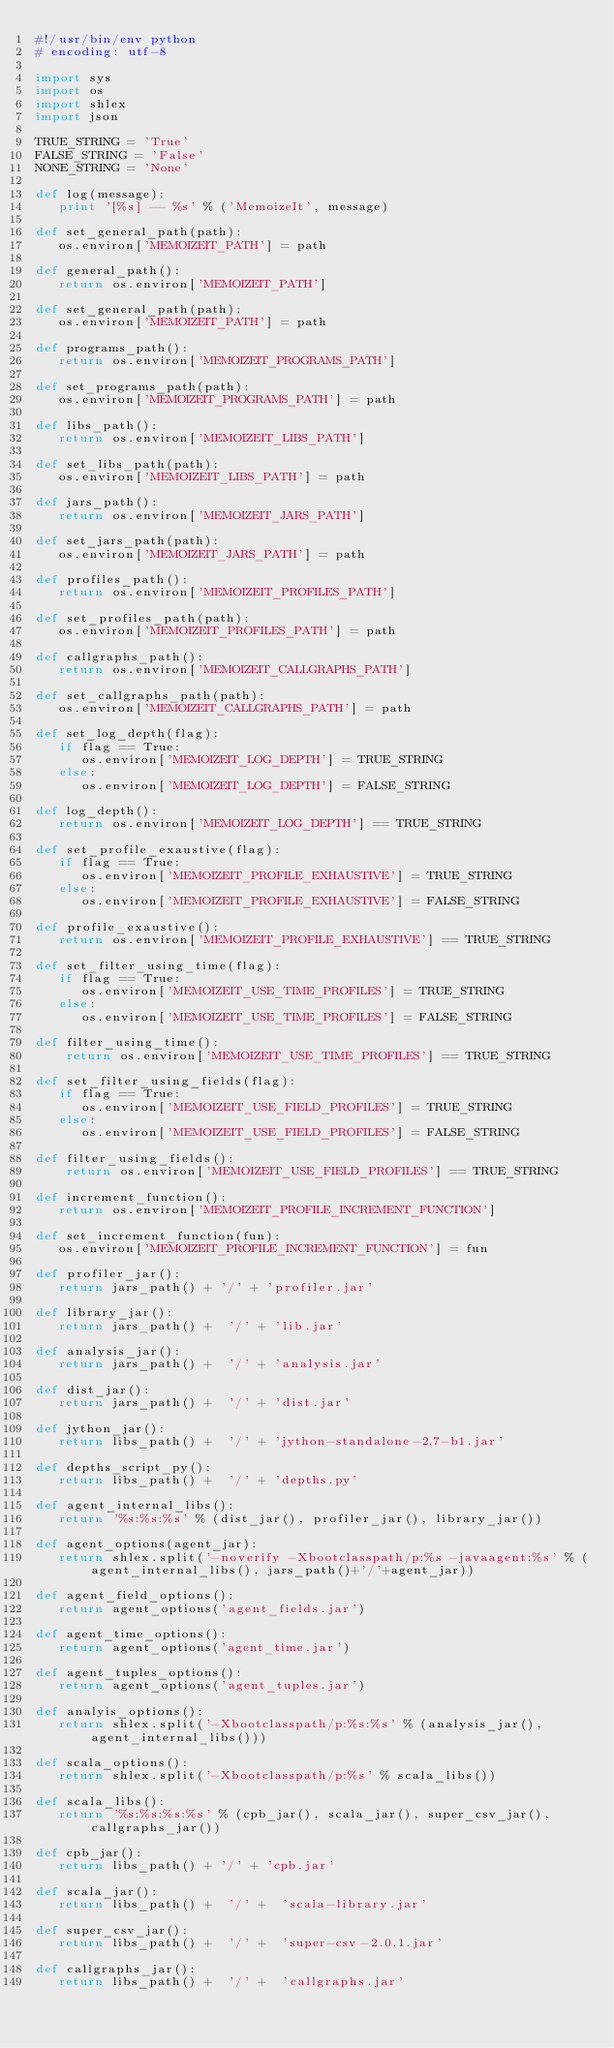Convert code to text. <code><loc_0><loc_0><loc_500><loc_500><_Python_>#!/usr/bin/env python
# encoding: utf-8

import sys
import os
import shlex
import json

TRUE_STRING = 'True'
FALSE_STRING = 'False'
NONE_STRING = 'None'

def log(message):
   print '[%s] -- %s' % ('MemoizeIt', message)
   
def set_general_path(path):
   os.environ['MEMOIZEIT_PATH'] = path   
   
def general_path():
   return os.environ['MEMOIZEIT_PATH']

def set_general_path(path):
   os.environ['MEMOIZEIT_PATH'] = path

def programs_path():
   return os.environ['MEMOIZEIT_PROGRAMS_PATH']

def set_programs_path(path):
   os.environ['MEMOIZEIT_PROGRAMS_PATH'] = path

def libs_path():
   return os.environ['MEMOIZEIT_LIBS_PATH']

def set_libs_path(path):
   os.environ['MEMOIZEIT_LIBS_PATH'] = path
 
def jars_path():
   return os.environ['MEMOIZEIT_JARS_PATH']

def set_jars_path(path):
   os.environ['MEMOIZEIT_JARS_PATH'] = path
   
def profiles_path():
   return os.environ['MEMOIZEIT_PROFILES_PATH']

def set_profiles_path(path):
   os.environ['MEMOIZEIT_PROFILES_PATH'] = path

def callgraphs_path():
   return os.environ['MEMOIZEIT_CALLGRAPHS_PATH']

def set_callgraphs_path(path):
   os.environ['MEMOIZEIT_CALLGRAPHS_PATH'] = path

def set_log_depth(flag):
   if flag == True:
      os.environ['MEMOIZEIT_LOG_DEPTH'] = TRUE_STRING
   else:
      os.environ['MEMOIZEIT_LOG_DEPTH'] = FALSE_STRING
      
def log_depth():
   return os.environ['MEMOIZEIT_LOG_DEPTH'] == TRUE_STRING

def set_profile_exaustive(flag):
   if flag == True:
      os.environ['MEMOIZEIT_PROFILE_EXHAUSTIVE'] = TRUE_STRING
   else:
      os.environ['MEMOIZEIT_PROFILE_EXHAUSTIVE'] = FALSE_STRING
      
def profile_exaustive():
   return os.environ['MEMOIZEIT_PROFILE_EXHAUSTIVE'] == TRUE_STRING

def set_filter_using_time(flag):
   if flag == True:
      os.environ['MEMOIZEIT_USE_TIME_PROFILES'] = TRUE_STRING
   else:
      os.environ['MEMOIZEIT_USE_TIME_PROFILES'] = FALSE_STRING
     
def filter_using_time():
    return os.environ['MEMOIZEIT_USE_TIME_PROFILES'] == TRUE_STRING

def set_filter_using_fields(flag):
   if flag == True:
      os.environ['MEMOIZEIT_USE_FIELD_PROFILES'] = TRUE_STRING
   else:
      os.environ['MEMOIZEIT_USE_FIELD_PROFILES'] = FALSE_STRING

def filter_using_fields():
    return os.environ['MEMOIZEIT_USE_FIELD_PROFILES'] == TRUE_STRING

def increment_function():
   return os.environ['MEMOIZEIT_PROFILE_INCREMENT_FUNCTION']  

def set_increment_function(fun):
   os.environ['MEMOIZEIT_PROFILE_INCREMENT_FUNCTION'] = fun  
   
def profiler_jar():
   return jars_path() + '/' + 'profiler.jar'

def library_jar():
   return jars_path() +  '/' + 'lib.jar'

def analysis_jar():
   return jars_path() +  '/' + 'analysis.jar'
   
def dist_jar():
   return jars_path() +  '/' + 'dist.jar'

def jython_jar():
   return libs_path() +  '/' + 'jython-standalone-2.7-b1.jar'

def depths_script_py():
   return libs_path() +  '/' + 'depths.py'
               
def agent_internal_libs():
   return '%s:%s:%s' % (dist_jar(), profiler_jar(), library_jar())

def agent_options(agent_jar):
   return shlex.split('-noverify -Xbootclasspath/p:%s -javaagent:%s' % (agent_internal_libs(), jars_path()+'/'+agent_jar))

def agent_field_options():
   return agent_options('agent_fields.jar')
   
def agent_time_options():
   return agent_options('agent_time.jar')

def agent_tuples_options():
   return agent_options('agent_tuples.jar')

def analyis_options():
   return shlex.split('-Xbootclasspath/p:%s:%s' % (analysis_jar(), agent_internal_libs()))

def scala_options():
   return shlex.split('-Xbootclasspath/p:%s' % scala_libs())

def scala_libs():
   return '%s:%s:%s:%s' % (cpb_jar(), scala_jar(), super_csv_jar(), callgraphs_jar())

def cpb_jar():
   return libs_path() + '/' + 'cpb.jar'

def scala_jar():
   return libs_path() +  '/' +  'scala-library.jar'

def super_csv_jar():
   return libs_path() +  '/' +  'super-csv-2.0.1.jar'

def callgraphs_jar():
   return libs_path() +  '/' +  'callgraphs.jar' 
</code> 